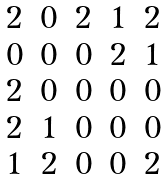Convert formula to latex. <formula><loc_0><loc_0><loc_500><loc_500>\begin{matrix} 2 & 0 & 2 & 1 & 2 \\ 0 & 0 & 0 & 2 & 1 \\ 2 & 0 & 0 & 0 & 0 \\ 2 & 1 & 0 & 0 & 0 \\ 1 & 2 & 0 & 0 & 2 \end{matrix}</formula> 